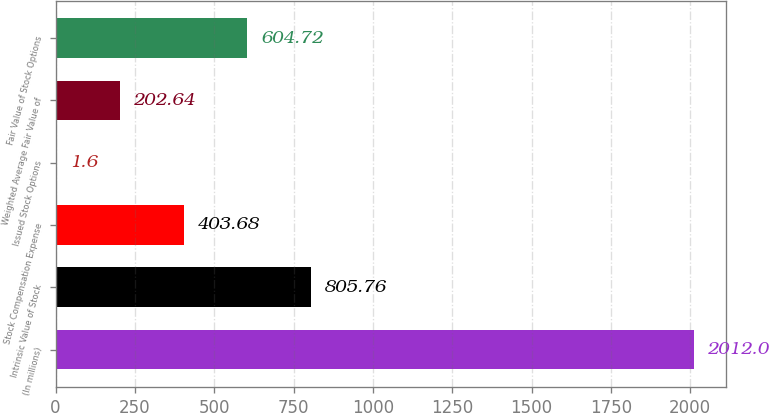<chart> <loc_0><loc_0><loc_500><loc_500><bar_chart><fcel>(In millions)<fcel>Intrinsic Value of Stock<fcel>Stock Compensation Expense<fcel>Issued Stock Options<fcel>Weighted Average Fair Value of<fcel>Fair Value of Stock Options<nl><fcel>2012<fcel>805.76<fcel>403.68<fcel>1.6<fcel>202.64<fcel>604.72<nl></chart> 